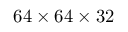<formula> <loc_0><loc_0><loc_500><loc_500>6 4 \times 6 4 \times 3 2</formula> 